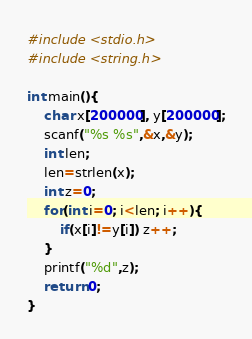<code> <loc_0><loc_0><loc_500><loc_500><_C_>#include <stdio.h>
#include <string.h>

int main(){
	char x[200000], y[200000];
	scanf("%s %s",&x,&y);
	int len;
	len=strlen(x);
	int z=0;
	for(int i=0; i<len; i++){
		if(x[i]!=y[i]) z++;
	}
	printf("%d",z);
	return 0;
}</code> 